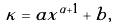<formula> <loc_0><loc_0><loc_500><loc_500>\kappa = a x ^ { \alpha + 1 } + b ,</formula> 